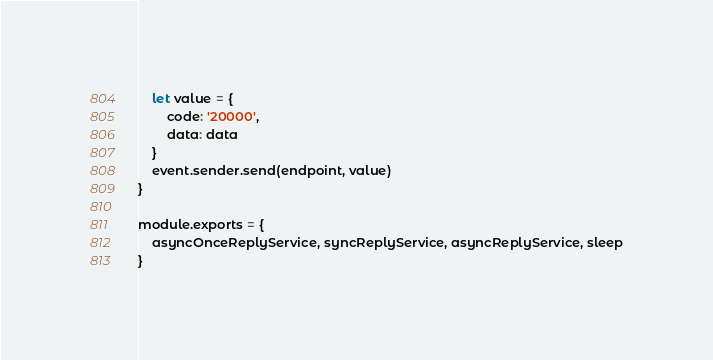Convert code to text. <code><loc_0><loc_0><loc_500><loc_500><_JavaScript_>    let value = {
        code: '20000',
        data: data
    }
    event.sender.send(endpoint, value)
}

module.exports = {
    asyncOnceReplyService, syncReplyService, asyncReplyService, sleep
}
</code> 